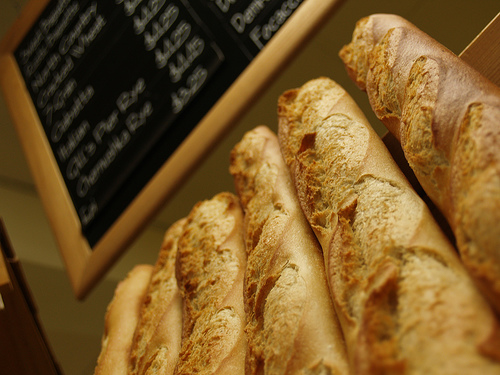<image>
Is there a baguette next to the baguette? Yes. The baguette is positioned adjacent to the baguette, located nearby in the same general area. 